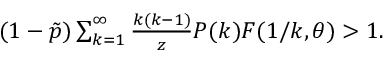Convert formula to latex. <formula><loc_0><loc_0><loc_500><loc_500>\begin{array} { r } { ( 1 - \tilde { p } ) \sum _ { k = 1 } ^ { \infty } \frac { k ( k - 1 ) } { z } P ( k ) F ( 1 / k , \theta ) > 1 . } \end{array}</formula> 